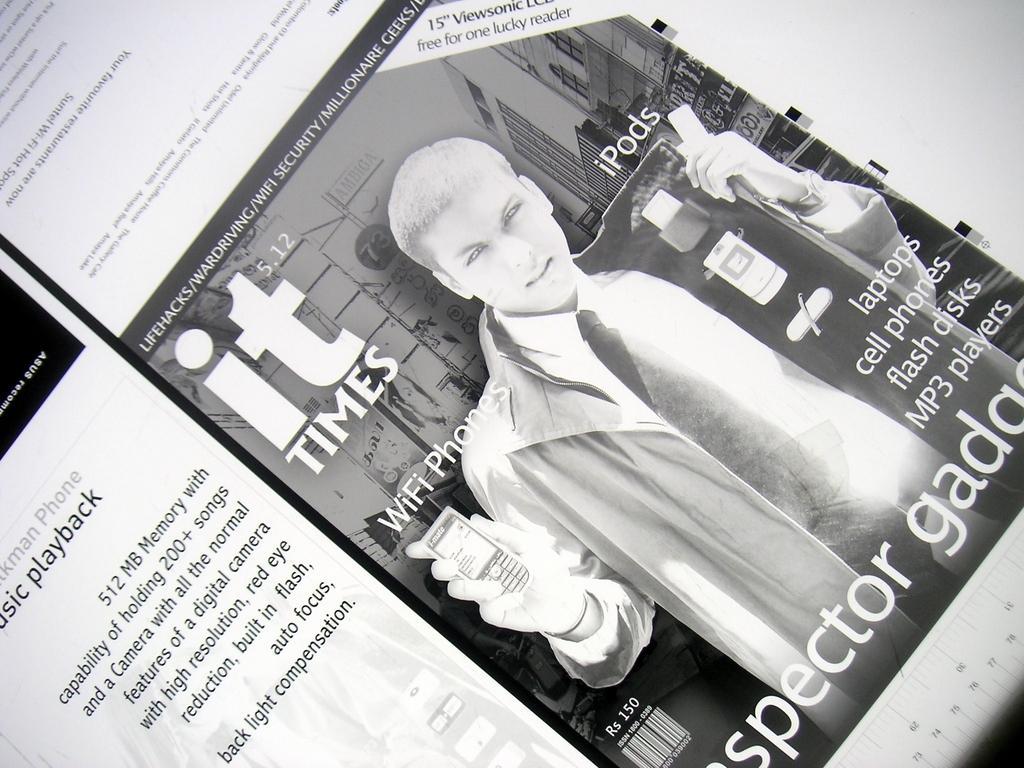Please provide a concise description of this image. This black and white image is rotated towards the right. I can see a paper cutting with some text and photo graph of a person holding a cellphone in his hand and accessories in his coat.  